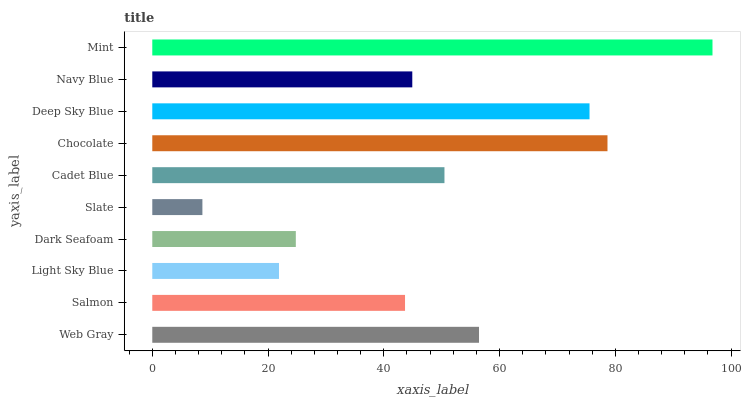Is Slate the minimum?
Answer yes or no. Yes. Is Mint the maximum?
Answer yes or no. Yes. Is Salmon the minimum?
Answer yes or no. No. Is Salmon the maximum?
Answer yes or no. No. Is Web Gray greater than Salmon?
Answer yes or no. Yes. Is Salmon less than Web Gray?
Answer yes or no. Yes. Is Salmon greater than Web Gray?
Answer yes or no. No. Is Web Gray less than Salmon?
Answer yes or no. No. Is Cadet Blue the high median?
Answer yes or no. Yes. Is Navy Blue the low median?
Answer yes or no. Yes. Is Salmon the high median?
Answer yes or no. No. Is Mint the low median?
Answer yes or no. No. 